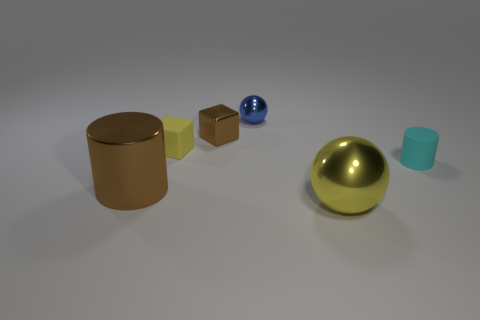Subtract all balls. How many objects are left? 4 Subtract 1 cubes. How many cubes are left? 1 Subtract all yellow blocks. How many yellow balls are left? 1 Add 3 small cyan rubber objects. How many small cyan rubber objects are left? 4 Add 3 cyan objects. How many cyan objects exist? 4 Add 1 small red objects. How many objects exist? 7 Subtract 0 green cylinders. How many objects are left? 6 Subtract all brown spheres. Subtract all purple cubes. How many spheres are left? 2 Subtract all yellow metal things. Subtract all brown shiny cylinders. How many objects are left? 4 